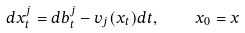Convert formula to latex. <formula><loc_0><loc_0><loc_500><loc_500>d x ^ { j } _ { t } = d b ^ { j } _ { t } - v _ { j } ( x _ { t } ) d t , \quad x _ { 0 } = x</formula> 